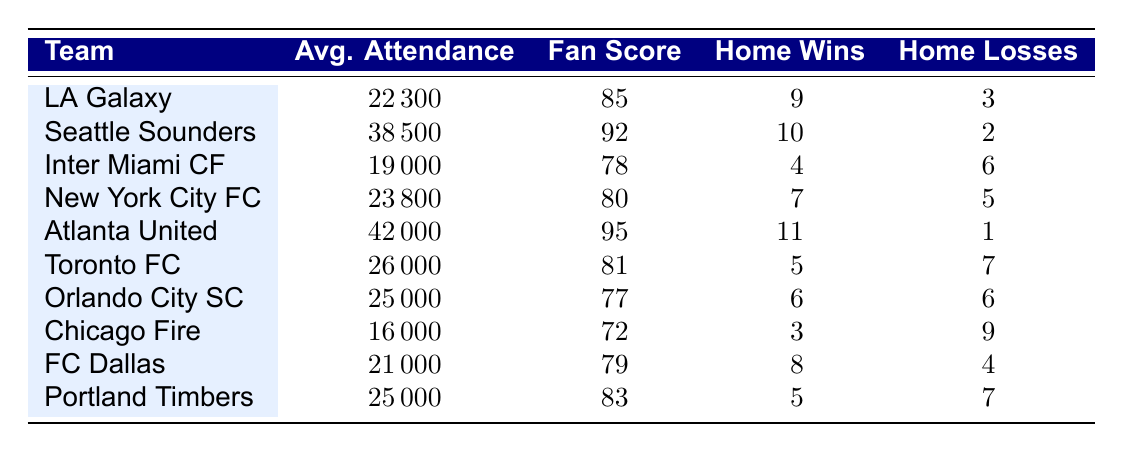What is the average attendance for Atlanta United? The table lists Atlanta United with an average attendance of 42,000.
Answer: 42,000 Which team has the highest fan engagement score? By comparing the fan engagement scores listed in the table, Atlanta United has the highest score of 95.
Answer: Atlanta United How many home wins does the LA Galaxy have? The table indicates that LA Galaxy has 9 home wins.
Answer: 9 What is the difference in average attendance between Seattle Sounders and Inter Miami CF? The average attendance for Seattle Sounders is 38,500, while Inter Miami CF's average is 19,000. The difference is 38,500 - 19,000 = 19,500.
Answer: 19,500 Is the fan engagement score of Chicago Fire greater than 75? The table shows that Chicago Fire has a fan engagement score of 72, which is less than 75.
Answer: No What is the total number of home losses for all teams? The total home losses can be calculated by adding each team's home losses: 3 + 2 + 6 + 5 + 1 + 7 + 6 + 9 + 4 + 7 = 50.
Answer: 50 What percentage of home games did FC Dallas win? FC Dallas has 8 home wins out of a total of 12 home games (8 wins + 4 losses). To find the percentage: (8/12) * 100 = 66.67%.
Answer: 66.67% Which team has the lowest average attendance and how many wins do they have? The team with the lowest average attendance is Chicago Fire, which has an average attendance of 16,000 and 3 home wins.
Answer: Chicago Fire, 3 wins If we take the average fan engagement score of New York City FC and Toronto FC, what is it? New York City FC has a score of 80, and Toronto FC has a score of 81. The average is (80 + 81) / 2 = 80.5.
Answer: 80.5 Which team has a higher home win to loss ratio: Orlando City SC or FC Dallas? Orlando City SC has 6 wins and 6 losses (ratio = 1), while FC Dallas has 8 wins and 4 losses (ratio = 2). FC Dallas has a higher ratio.
Answer: FC Dallas 